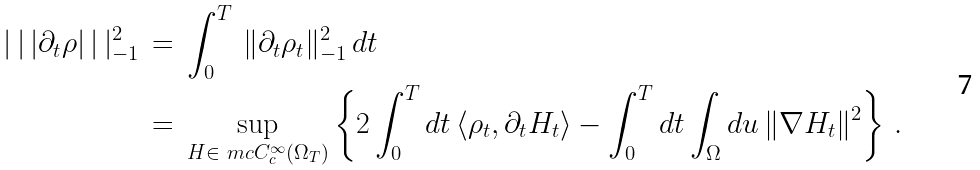Convert formula to latex. <formula><loc_0><loc_0><loc_500><loc_500>| \, | \, | \partial _ { t } \rho | \, | \, | ^ { 2 } _ { - 1 } \, & = \, \int _ { 0 } ^ { T } \, \| \partial _ { t } \rho _ { t } \| ^ { 2 } _ { - 1 } \, d t \\ & = \, \sup _ { H \in \ m c C ^ { \infty } _ { c } ( \Omega _ { T } ) } \left \{ 2 \int _ { 0 } ^ { T } d t \, \langle \rho _ { t } , \partial _ { t } H _ { t } \rangle - \int _ { 0 } ^ { T } d t \int _ { \Omega } d u \, \| \nabla H _ { t } \| ^ { 2 } \right \} \, .</formula> 